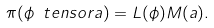<formula> <loc_0><loc_0><loc_500><loc_500>\pi ( \phi \ t e n s o r a ) = L ( \phi ) M ( a ) .</formula> 